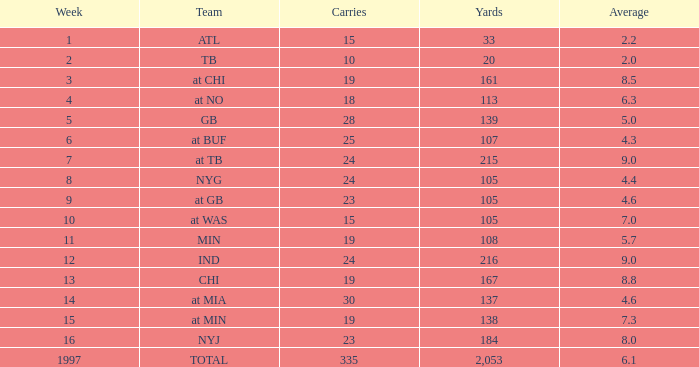Which group possesses 19 carries and a week exceeding 13? At min. 